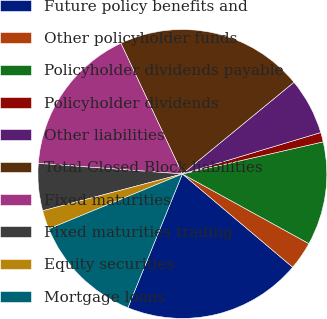Convert chart to OTSL. <chart><loc_0><loc_0><loc_500><loc_500><pie_chart><fcel>Future policy benefits and<fcel>Other policyholder funds<fcel>Policyholder dividends payable<fcel>Policyholder dividends<fcel>Other liabilities<fcel>Total Closed Block liabilities<fcel>Fixed maturities<fcel>Fixed maturities trading<fcel>Equity securities<fcel>Mortgage loans<nl><fcel>19.99%<fcel>3.16%<fcel>11.58%<fcel>1.06%<fcel>6.32%<fcel>21.05%<fcel>16.84%<fcel>5.27%<fcel>2.11%<fcel>12.63%<nl></chart> 